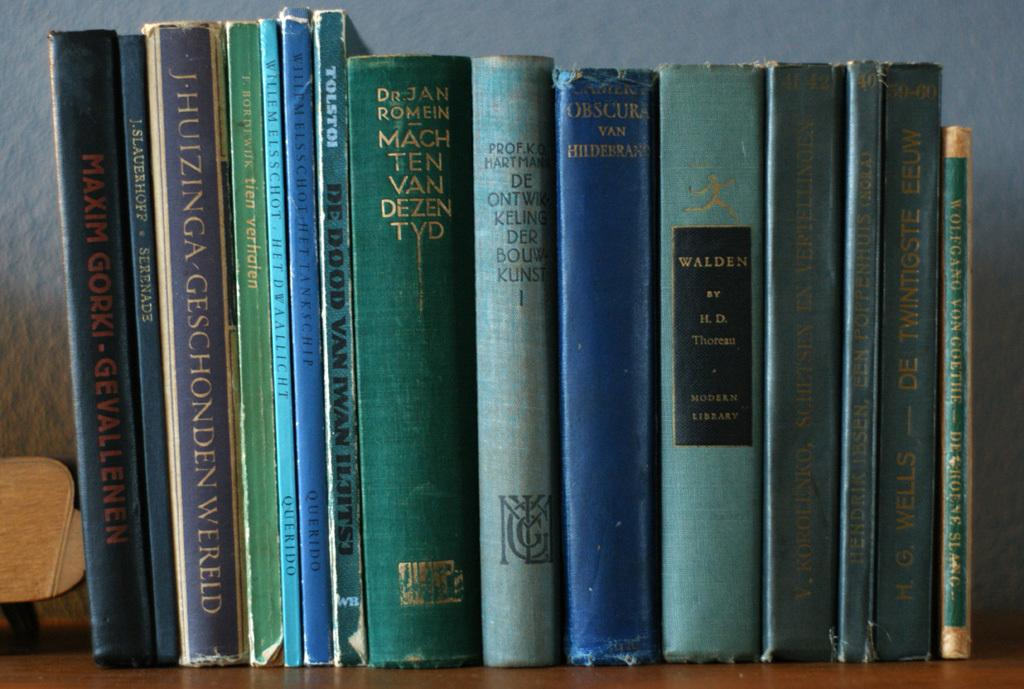<image>
Create a compact narrative representing the image presented. Several spines of books that are on a shelf including the title Walden. 